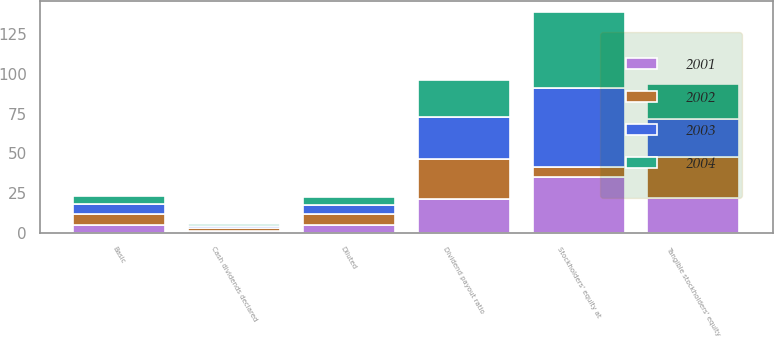<chart> <loc_0><loc_0><loc_500><loc_500><stacked_bar_chart><ecel><fcel>Basic<fcel>Diluted<fcel>Cash dividends declared<fcel>Stockholders' equity at<fcel>Tangible stockholders' equity<fcel>Dividend payout ratio<nl><fcel>2002<fcel>6.88<fcel>6.73<fcel>1.75<fcel>6.88<fcel>25.91<fcel>25.42<nl><fcel>2003<fcel>6.14<fcel>6<fcel>1.6<fcel>49.68<fcel>23.62<fcel>26<nl><fcel>2004<fcel>5.08<fcel>4.95<fcel>1.2<fcel>47.55<fcel>21.97<fcel>23.62<nl><fcel>2001<fcel>4.94<fcel>4.78<fcel>1.05<fcel>34.82<fcel>22.04<fcel>21.24<nl></chart> 